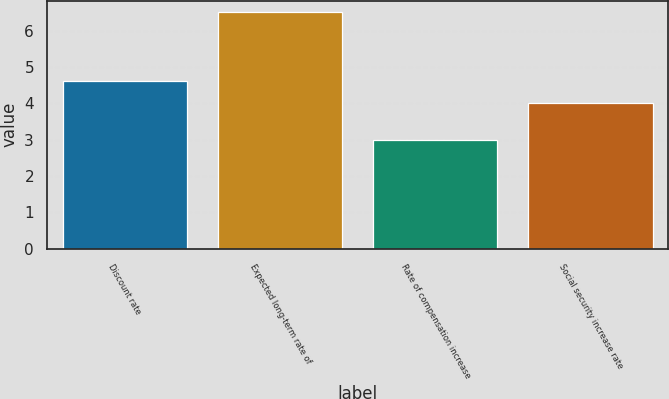Convert chart to OTSL. <chart><loc_0><loc_0><loc_500><loc_500><bar_chart><fcel>Discount rate<fcel>Expected long-term rate of<fcel>Rate of compensation increase<fcel>Social security increase rate<nl><fcel>4.6<fcel>6.5<fcel>3<fcel>4<nl></chart> 